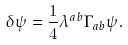Convert formula to latex. <formula><loc_0><loc_0><loc_500><loc_500>\delta \psi = \frac { 1 } { 4 } \lambda ^ { a b } \Gamma _ { a b } \psi .</formula> 